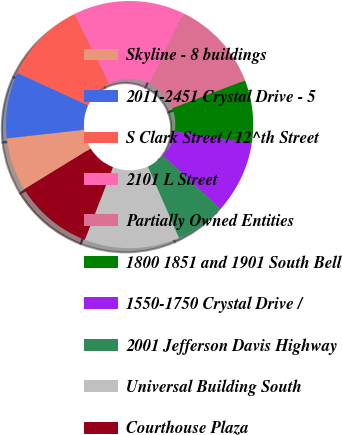Convert chart. <chart><loc_0><loc_0><loc_500><loc_500><pie_chart><fcel>Skyline - 8 buildings<fcel>2011-2451 Crystal Drive - 5<fcel>S Clark Street / 12^th Street<fcel>2101 L Street<fcel>Partially Owned Entities<fcel>1800 1851 and 1901 South Bell<fcel>1550-1750 Crystal Drive /<fcel>2001 Jefferson Davis Highway<fcel>Universal Building South<fcel>Courthouse Plaza<nl><fcel>6.98%<fcel>8.66%<fcel>10.76%<fcel>14.53%<fcel>12.02%<fcel>8.24%<fcel>9.5%<fcel>6.56%<fcel>12.43%<fcel>10.34%<nl></chart> 